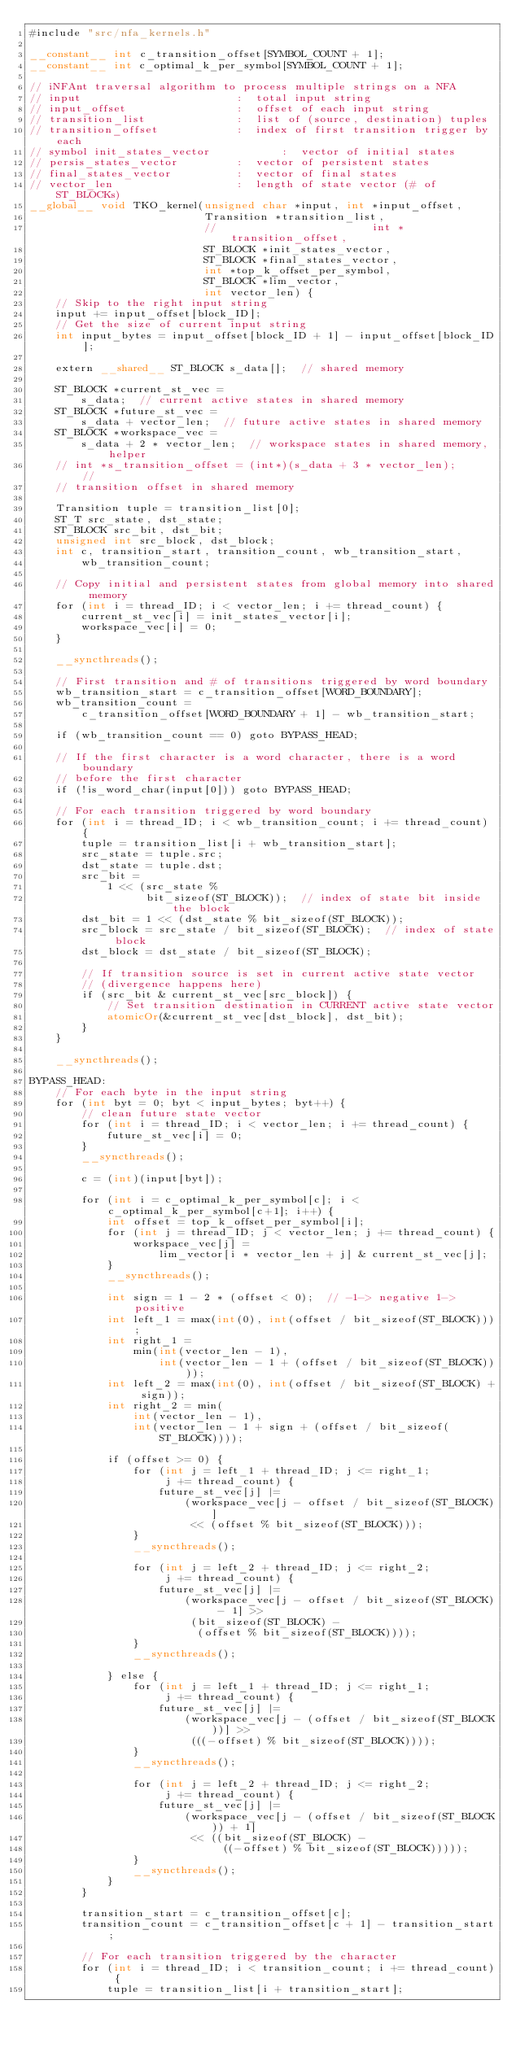<code> <loc_0><loc_0><loc_500><loc_500><_Cuda_>#include "src/nfa_kernels.h"

__constant__ int c_transition_offset[SYMBOL_COUNT + 1];
__constant__ int c_optimal_k_per_symbol[SYMBOL_COUNT + 1];

// iNFAnt traversal algorithm to process multiple strings on a NFA
// input                        :  total input string
// input_offset                 :  offset of each input string
// transition_list              :  list of (source, destination) tuples
// transition_offset            :  index of first transition trigger by each
// symbol init_states_vector           :  vector of initial states
// persis_states_vector         :  vector of persistent states
// final_states_vector          :  vector of final states
// vector_len                   :  length of state vector (# of ST_BLOCKs)
__global__ void TKO_kernel(unsigned char *input, int *input_offset,
                           Transition *transition_list,
                           //                        int *transition_offset,
                           ST_BLOCK *init_states_vector,
                           ST_BLOCK *final_states_vector,
                           int *top_k_offset_per_symbol,
                           ST_BLOCK *lim_vector,
                           int vector_len) {
    // Skip to the right input string
    input += input_offset[block_ID];
    // Get the size of current input string
    int input_bytes = input_offset[block_ID + 1] - input_offset[block_ID];

    extern __shared__ ST_BLOCK s_data[];  // shared memory

    ST_BLOCK *current_st_vec =
        s_data;  // current active states in shared memory
    ST_BLOCK *future_st_vec =
        s_data + vector_len;  // future active states in shared memory
    ST_BLOCK *workspace_vec =
        s_data + 2 * vector_len;  // workspace states in shared memory, helper
    // int *s_transition_offset = (int*)(s_data + 3 * vector_len);     //
    // transition offset in shared memory

    Transition tuple = transition_list[0];
    ST_T src_state, dst_state;
    ST_BLOCK src_bit, dst_bit;
    unsigned int src_block, dst_block;
    int c, transition_start, transition_count, wb_transition_start,
        wb_transition_count;

    // Copy initial and persistent states from global memory into shared memory
    for (int i = thread_ID; i < vector_len; i += thread_count) {
        current_st_vec[i] = init_states_vector[i];
        workspace_vec[i] = 0;
    }

    __syncthreads();

    // First transition and # of transitions triggered by word boundary
    wb_transition_start = c_transition_offset[WORD_BOUNDARY];
    wb_transition_count =
        c_transition_offset[WORD_BOUNDARY + 1] - wb_transition_start;

    if (wb_transition_count == 0) goto BYPASS_HEAD;

    // If the first character is a word character, there is a word boundary
    // before the first character
    if (!is_word_char(input[0])) goto BYPASS_HEAD;

    // For each transition triggered by word boundary
    for (int i = thread_ID; i < wb_transition_count; i += thread_count) {
        tuple = transition_list[i + wb_transition_start];
        src_state = tuple.src;
        dst_state = tuple.dst;
        src_bit =
            1 << (src_state %
                  bit_sizeof(ST_BLOCK));  // index of state bit inside the block
        dst_bit = 1 << (dst_state % bit_sizeof(ST_BLOCK));
        src_block = src_state / bit_sizeof(ST_BLOCK);  // index of state block
        dst_block = dst_state / bit_sizeof(ST_BLOCK);

        // If transition source is set in current active state vector
        // (divergence happens here)
        if (src_bit & current_st_vec[src_block]) {
            // Set transition destination in CURRENT active state vector
            atomicOr(&current_st_vec[dst_block], dst_bit);
        }
    }

    __syncthreads();

BYPASS_HEAD:
    // For each byte in the input string
    for (int byt = 0; byt < input_bytes; byt++) {
        // clean future state vector
        for (int i = thread_ID; i < vector_len; i += thread_count) {
            future_st_vec[i] = 0;
        }
        __syncthreads();

        c = (int)(input[byt]);

        for (int i = c_optimal_k_per_symbol[c]; i < c_optimal_k_per_symbol[c+1]; i++) {
            int offset = top_k_offset_per_symbol[i];
            for (int j = thread_ID; j < vector_len; j += thread_count) {
                workspace_vec[j] =
                    lim_vector[i * vector_len + j] & current_st_vec[j];
            }
            __syncthreads();

            int sign = 1 - 2 * (offset < 0);  // -1-> negative 1->positive
            int left_1 = max(int(0), int(offset / bit_sizeof(ST_BLOCK)));
            int right_1 =
                min(int(vector_len - 1),
                    int(vector_len - 1 + (offset / bit_sizeof(ST_BLOCK))));
            int left_2 = max(int(0), int(offset / bit_sizeof(ST_BLOCK) + sign));
            int right_2 = min(
                int(vector_len - 1),
                int(vector_len - 1 + sign + (offset / bit_sizeof(ST_BLOCK))));

            if (offset >= 0) {
                for (int j = left_1 + thread_ID; j <= right_1;
                     j += thread_count) {
                    future_st_vec[j] |=
                        (workspace_vec[j - offset / bit_sizeof(ST_BLOCK)]
                         << (offset % bit_sizeof(ST_BLOCK)));
                }
                __syncthreads();

                for (int j = left_2 + thread_ID; j <= right_2;
                     j += thread_count) {
                    future_st_vec[j] |=
                        (workspace_vec[j - offset / bit_sizeof(ST_BLOCK) - 1] >>
                         (bit_sizeof(ST_BLOCK) -
                          (offset % bit_sizeof(ST_BLOCK))));
                }
                __syncthreads();

            } else {
                for (int j = left_1 + thread_ID; j <= right_1;
                     j += thread_count) {
                    future_st_vec[j] |=
                        (workspace_vec[j - (offset / bit_sizeof(ST_BLOCK))] >>
                         (((-offset) % bit_sizeof(ST_BLOCK))));
                }
                __syncthreads();

                for (int j = left_2 + thread_ID; j <= right_2;
                     j += thread_count) {
                    future_st_vec[j] |=
                        (workspace_vec[j - (offset / bit_sizeof(ST_BLOCK)) + 1]
                         << ((bit_sizeof(ST_BLOCK) -
                              ((-offset) % bit_sizeof(ST_BLOCK)))));
                }
                __syncthreads();
            }
        }

        transition_start = c_transition_offset[c];
        transition_count = c_transition_offset[c + 1] - transition_start;

        // For each transition triggered by the character
        for (int i = thread_ID; i < transition_count; i += thread_count) {
            tuple = transition_list[i + transition_start];</code> 